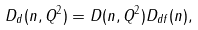<formula> <loc_0><loc_0><loc_500><loc_500>D _ { d } ( n , Q ^ { 2 } ) = D ( n , Q ^ { 2 } ) D _ { d f } ( n ) ,</formula> 